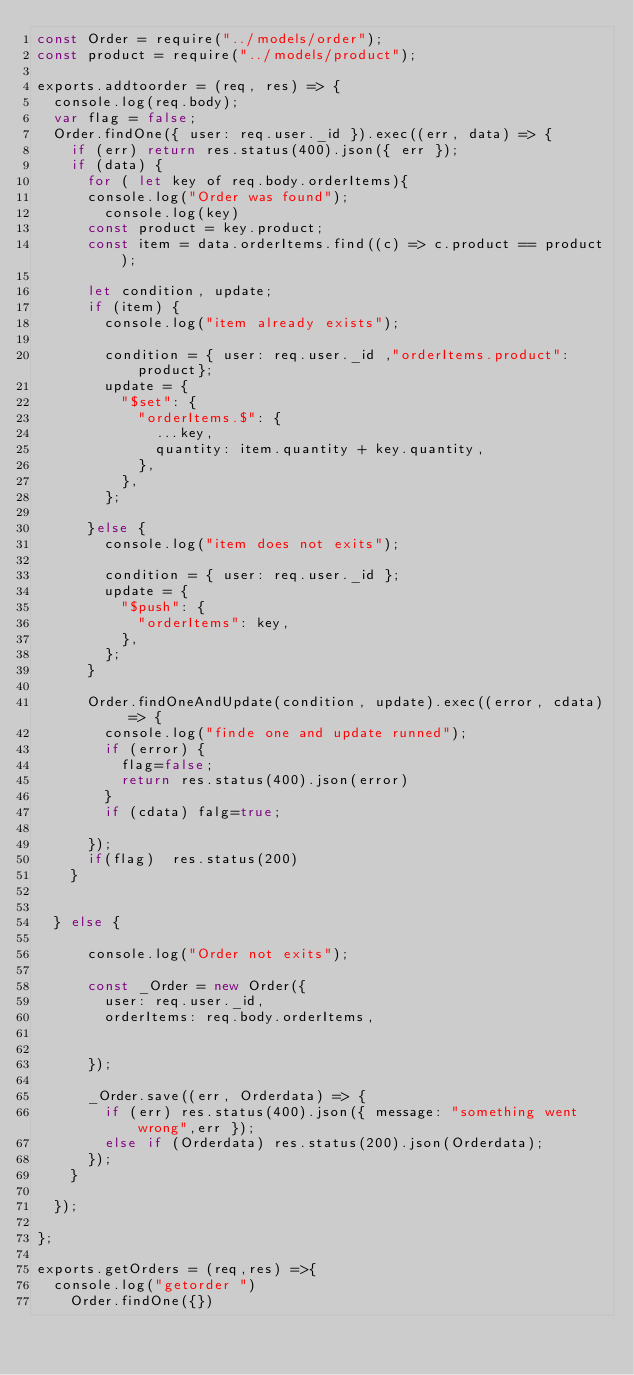Convert code to text. <code><loc_0><loc_0><loc_500><loc_500><_JavaScript_>const Order = require("../models/order");
const product = require("../models/product");

exports.addtoorder = (req, res) => {
  console.log(req.body);
  var flag = false;
  Order.findOne({ user: req.user._id }).exec((err, data) => {
    if (err) return res.status(400).json({ err });
    if (data) {
      for ( let key of req.body.orderItems){
      console.log("Order was found");
        console.log(key)
      const product = key.product;
      const item = data.orderItems.find((c) => c.product == product);

      let condition, update;
      if (item) {
        console.log("item already exists");

        condition = { user: req.user._id ,"orderItems.product": product};
        update = {
          "$set": {
            "orderItems.$": {
              ...key,
              quantity: item.quantity + key.quantity,
            },
          },
        };

      }else {
        console.log("item does not exits");

        condition = { user: req.user._id };
        update = {
          "$push": {
            "orderItems": key,
          },
        };
      }

      Order.findOneAndUpdate(condition, update).exec((error, cdata) => {
        console.log("finde one and update runned");
        if (error) {
          flag=false;
          return res.status(400).json(error)
        }
        if (cdata) falg=true;

      });
      if(flag)  res.status(200)
    }
    

  } else {

      console.log("Order not exits");
      
      const _Order = new Order({
        user: req.user._id,
        orderItems: req.body.orderItems,


      });

      _Order.save((err, Orderdata) => {
        if (err) res.status(400).json({ message: "something went wrong",err });
        else if (Orderdata) res.status(200).json(Orderdata);
      });
    }
  
  });

};

exports.getOrders = (req,res) =>{
  console.log("getorder ")
    Order.findOne({})</code> 